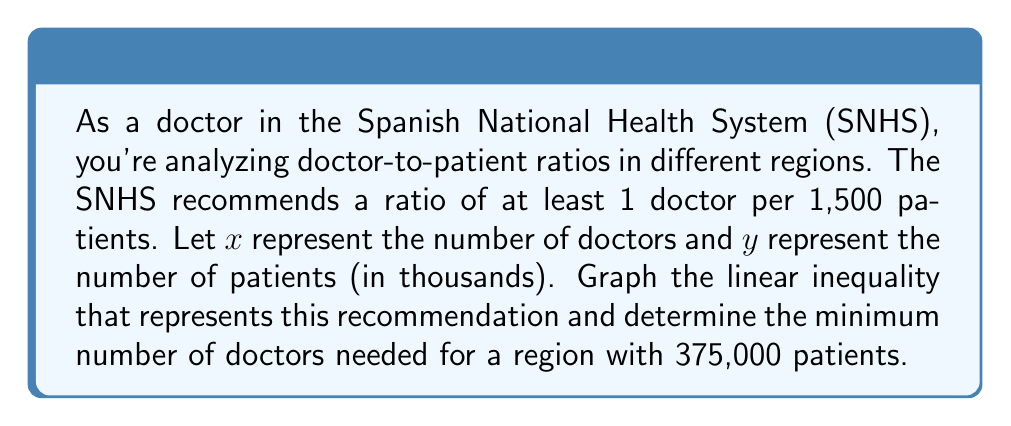Teach me how to tackle this problem. Let's approach this step-by-step:

1) First, we need to set up the inequality:
   
   $\frac{y}{x} \leq 1.5$ (as y is in thousands, 1,500 patients = 1.5)

2) We can rewrite this as:
   
   $y \leq 1.5x$

3) This is our linear inequality. To graph it:

   [asy]
   import graph;
   size(200);
   xaxis("Doctors (x)", 0, 300, Arrow);
   yaxis("Patients (y) in thousands", 0, 450, Arrow);
   draw((0,0)--(300,450), blue);
   fill((0,0)--(300,450)--(300,0)--cycle, blue+opacity(0.1));
   label("y ≤ 1.5x", (150,300), E);
   [/asy]

4) The shaded area represents all valid doctor-to-patient ratios.

5) Now, for 375,000 patients, $y = 375$ (remember, y is in thousands).

6) To find the minimum number of doctors, we solve:

   $375 = 1.5x$
   $x = 375 / 1.5 = 250$

7) Therefore, the region needs at least 250 doctors to meet the SNHS recommendation.
Answer: The minimum number of doctors needed for a region with 375,000 patients is 250. 